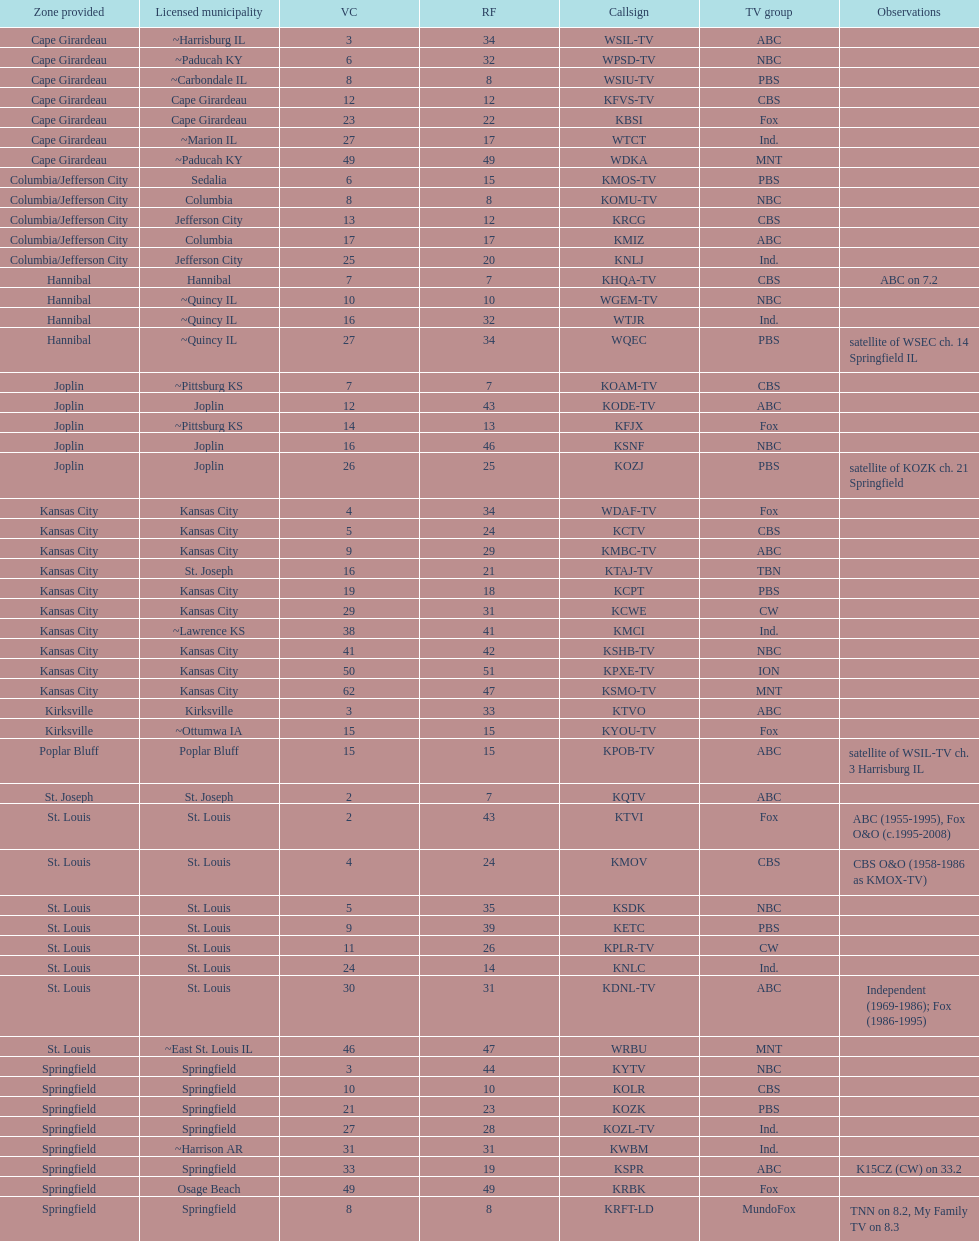Can you parse all the data within this table? {'header': ['Zone provided', 'Licensed municipality', 'VC', 'RF', 'Callsign', 'TV group', 'Observations'], 'rows': [['Cape Girardeau', '~Harrisburg IL', '3', '34', 'WSIL-TV', 'ABC', ''], ['Cape Girardeau', '~Paducah KY', '6', '32', 'WPSD-TV', 'NBC', ''], ['Cape Girardeau', '~Carbondale IL', '8', '8', 'WSIU-TV', 'PBS', ''], ['Cape Girardeau', 'Cape Girardeau', '12', '12', 'KFVS-TV', 'CBS', ''], ['Cape Girardeau', 'Cape Girardeau', '23', '22', 'KBSI', 'Fox', ''], ['Cape Girardeau', '~Marion IL', '27', '17', 'WTCT', 'Ind.', ''], ['Cape Girardeau', '~Paducah KY', '49', '49', 'WDKA', 'MNT', ''], ['Columbia/Jefferson City', 'Sedalia', '6', '15', 'KMOS-TV', 'PBS', ''], ['Columbia/Jefferson City', 'Columbia', '8', '8', 'KOMU-TV', 'NBC', ''], ['Columbia/Jefferson City', 'Jefferson City', '13', '12', 'KRCG', 'CBS', ''], ['Columbia/Jefferson City', 'Columbia', '17', '17', 'KMIZ', 'ABC', ''], ['Columbia/Jefferson City', 'Jefferson City', '25', '20', 'KNLJ', 'Ind.', ''], ['Hannibal', 'Hannibal', '7', '7', 'KHQA-TV', 'CBS', 'ABC on 7.2'], ['Hannibal', '~Quincy IL', '10', '10', 'WGEM-TV', 'NBC', ''], ['Hannibal', '~Quincy IL', '16', '32', 'WTJR', 'Ind.', ''], ['Hannibal', '~Quincy IL', '27', '34', 'WQEC', 'PBS', 'satellite of WSEC ch. 14 Springfield IL'], ['Joplin', '~Pittsburg KS', '7', '7', 'KOAM-TV', 'CBS', ''], ['Joplin', 'Joplin', '12', '43', 'KODE-TV', 'ABC', ''], ['Joplin', '~Pittsburg KS', '14', '13', 'KFJX', 'Fox', ''], ['Joplin', 'Joplin', '16', '46', 'KSNF', 'NBC', ''], ['Joplin', 'Joplin', '26', '25', 'KOZJ', 'PBS', 'satellite of KOZK ch. 21 Springfield'], ['Kansas City', 'Kansas City', '4', '34', 'WDAF-TV', 'Fox', ''], ['Kansas City', 'Kansas City', '5', '24', 'KCTV', 'CBS', ''], ['Kansas City', 'Kansas City', '9', '29', 'KMBC-TV', 'ABC', ''], ['Kansas City', 'St. Joseph', '16', '21', 'KTAJ-TV', 'TBN', ''], ['Kansas City', 'Kansas City', '19', '18', 'KCPT', 'PBS', ''], ['Kansas City', 'Kansas City', '29', '31', 'KCWE', 'CW', ''], ['Kansas City', '~Lawrence KS', '38', '41', 'KMCI', 'Ind.', ''], ['Kansas City', 'Kansas City', '41', '42', 'KSHB-TV', 'NBC', ''], ['Kansas City', 'Kansas City', '50', '51', 'KPXE-TV', 'ION', ''], ['Kansas City', 'Kansas City', '62', '47', 'KSMO-TV', 'MNT', ''], ['Kirksville', 'Kirksville', '3', '33', 'KTVO', 'ABC', ''], ['Kirksville', '~Ottumwa IA', '15', '15', 'KYOU-TV', 'Fox', ''], ['Poplar Bluff', 'Poplar Bluff', '15', '15', 'KPOB-TV', 'ABC', 'satellite of WSIL-TV ch. 3 Harrisburg IL'], ['St. Joseph', 'St. Joseph', '2', '7', 'KQTV', 'ABC', ''], ['St. Louis', 'St. Louis', '2', '43', 'KTVI', 'Fox', 'ABC (1955-1995), Fox O&O (c.1995-2008)'], ['St. Louis', 'St. Louis', '4', '24', 'KMOV', 'CBS', 'CBS O&O (1958-1986 as KMOX-TV)'], ['St. Louis', 'St. Louis', '5', '35', 'KSDK', 'NBC', ''], ['St. Louis', 'St. Louis', '9', '39', 'KETC', 'PBS', ''], ['St. Louis', 'St. Louis', '11', '26', 'KPLR-TV', 'CW', ''], ['St. Louis', 'St. Louis', '24', '14', 'KNLC', 'Ind.', ''], ['St. Louis', 'St. Louis', '30', '31', 'KDNL-TV', 'ABC', 'Independent (1969-1986); Fox (1986-1995)'], ['St. Louis', '~East St. Louis IL', '46', '47', 'WRBU', 'MNT', ''], ['Springfield', 'Springfield', '3', '44', 'KYTV', 'NBC', ''], ['Springfield', 'Springfield', '10', '10', 'KOLR', 'CBS', ''], ['Springfield', 'Springfield', '21', '23', 'KOZK', 'PBS', ''], ['Springfield', 'Springfield', '27', '28', 'KOZL-TV', 'Ind.', ''], ['Springfield', '~Harrison AR', '31', '31', 'KWBM', 'Ind.', ''], ['Springfield', 'Springfield', '33', '19', 'KSPR', 'ABC', 'K15CZ (CW) on 33.2'], ['Springfield', 'Osage Beach', '49', '49', 'KRBK', 'Fox', ''], ['Springfield', 'Springfield', '8', '8', 'KRFT-LD', 'MundoFox', 'TNN on 8.2, My Family TV on 8.3']]} What is the count of areas containing 5 or more stations? 6. 